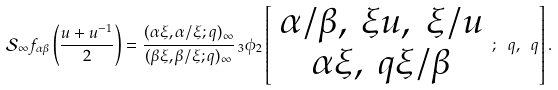<formula> <loc_0><loc_0><loc_500><loc_500>\mathcal { S } _ { \infty } f _ { \alpha \beta } \left ( \frac { u + u ^ { - 1 } } { 2 } \right ) = \frac { ( \alpha \xi , \alpha / \xi ; q ) _ { \infty } } { ( \beta \xi , \beta / \xi ; q ) _ { \infty } } \, _ { 3 } \phi _ { 2 } \left [ \begin{array} { c } \alpha / \beta , \ \xi u , \ \xi / u \\ \alpha \xi , \ q \xi / \beta \end{array} ; \ q , \ q \right ] .</formula> 